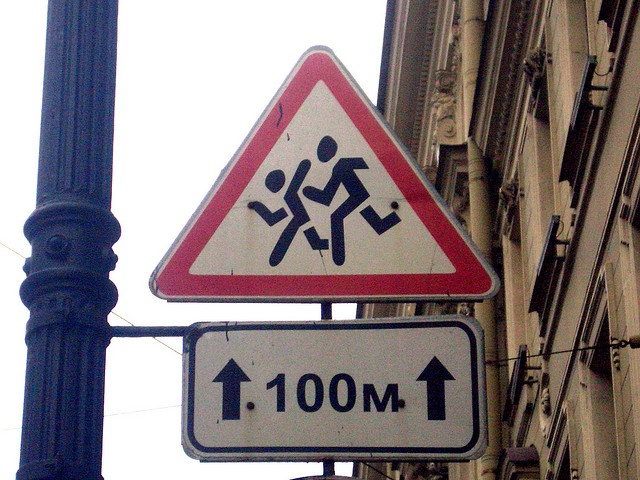Describe the objects in this image and their specific colors. I can see various objects in this image with different colors. 